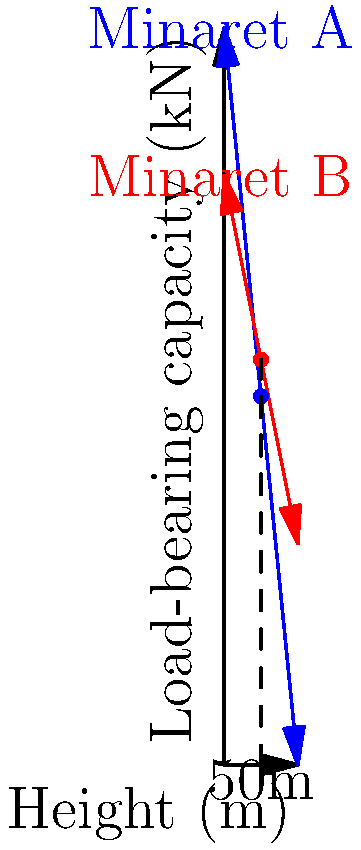My dear Imam, I noticed that the minarets in our mosque have different heights. I wonder, how does the height of a minaret affect its ability to carry weight? The graph shows the load-bearing capacity of two minarets (A and B) as their height increases. At a height of 50 meters, approximately how much more weight can Minaret A support compared to Minaret B? To answer this question, we need to follow these steps:

1. Understand the graph:
   - The x-axis represents the height of the minaret in meters.
   - The y-axis represents the load-bearing capacity in kilonewtons (kN).
   - The blue line represents Minaret A, and the red line represents Minaret B.

2. Locate the point on the graph for a height of 50 meters:
   - Draw a vertical line from the 50m mark on the x-axis.

3. Find the load-bearing capacity for Minaret A at 50m:
   - Follow the vertical line until it intersects the blue line (Minaret A).
   - Read the corresponding value on the y-axis: approximately 500 kN.

4. Find the load-bearing capacity for Minaret B at 50m:
   - Follow the vertical line until it intersects the red line (Minaret B).
   - Read the corresponding value on the y-axis: approximately 550 kN.

5. Calculate the difference:
   $500 \text{ kN} - 550 \text{ kN} = -50 \text{ kN}$

The negative value indicates that Minaret A actually supports less weight than Minaret B at 50 meters height.

6. Express the result as a positive difference:
   Minaret B can support approximately 50 kN more than Minaret A at a height of 50 meters.
Answer: Minaret B can support approximately 50 kN more than Minaret A at 50 meters height. 